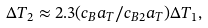Convert formula to latex. <formula><loc_0><loc_0><loc_500><loc_500>\Delta T _ { 2 } \approx 2 . 3 ( c _ { B } a _ { T } / c _ { B 2 } a _ { T } ) \Delta T _ { 1 } ,</formula> 